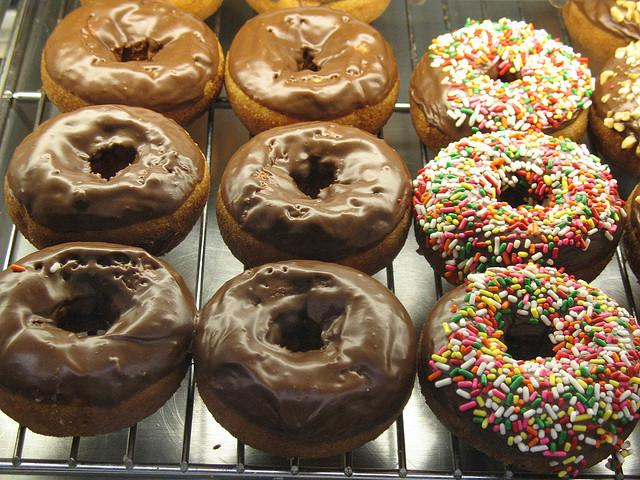These items are usually eaten for what? Please explain your reasoning. snack. These items are donuts. they are not eaten at meals or fancy weddings. 